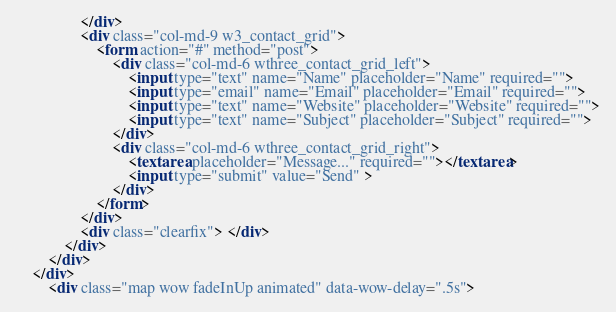Convert code to text. <code><loc_0><loc_0><loc_500><loc_500><_HTML_>				</div>
				<div class="col-md-9 w3_contact_grid">
					<form action="#" method="post">
						<div class="col-md-6 wthree_contact_grid_left">
							<input type="text" name="Name" placeholder="Name" required="">
							<input type="email" name="Email" placeholder="Email" required="">
							<input type="text" name="Website" placeholder="Website" required="">
							<input type="text" name="Subject" placeholder="Subject" required="">
						</div>
						<div class="col-md-6 wthree_contact_grid_right">
							<textarea placeholder="Message..." required=""></textarea>
							<input type="submit" value="Send" >
						</div>
					</form>
				</div>
				<div class="clearfix"> </div>
			</div>
		</div>
	</div>
		<div class="map wow fadeInUp animated" data-wow-delay=".5s"></code> 